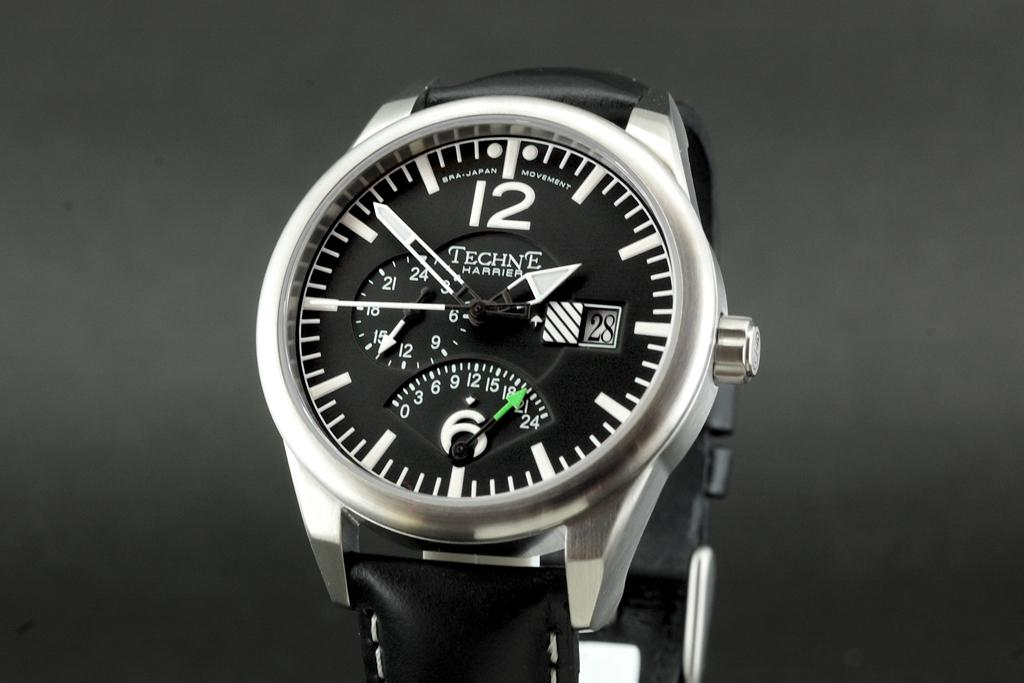<image>
Give a short and clear explanation of the subsequent image. A black and silver Techne Harrier watch on display against a grey background. 